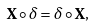<formula> <loc_0><loc_0><loc_500><loc_500>\mathbf X \circ \delta = \delta \circ \mathbf X ,</formula> 